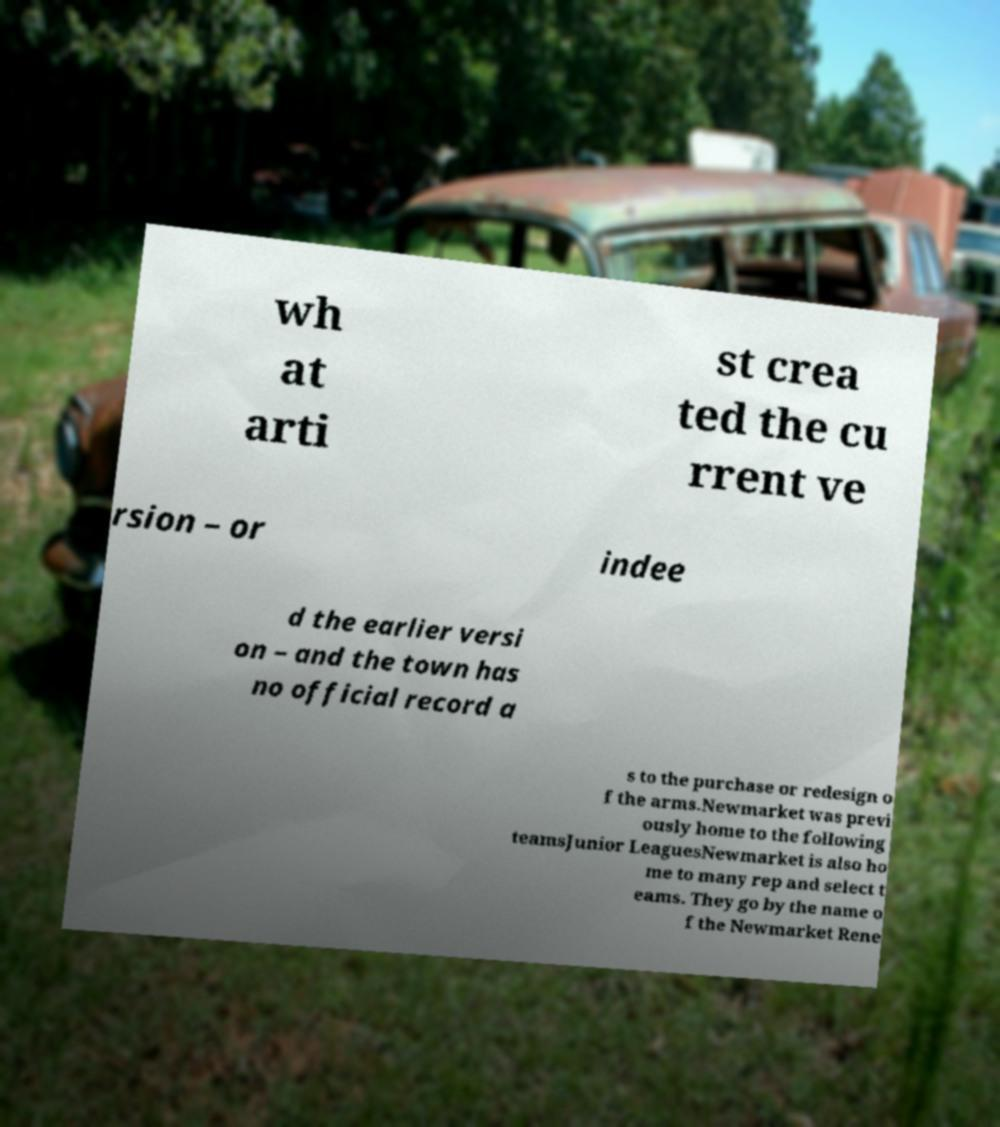Please identify and transcribe the text found in this image. wh at arti st crea ted the cu rrent ve rsion – or indee d the earlier versi on – and the town has no official record a s to the purchase or redesign o f the arms.Newmarket was previ ously home to the following teamsJunior LeaguesNewmarket is also ho me to many rep and select t eams. They go by the name o f the Newmarket Rene 